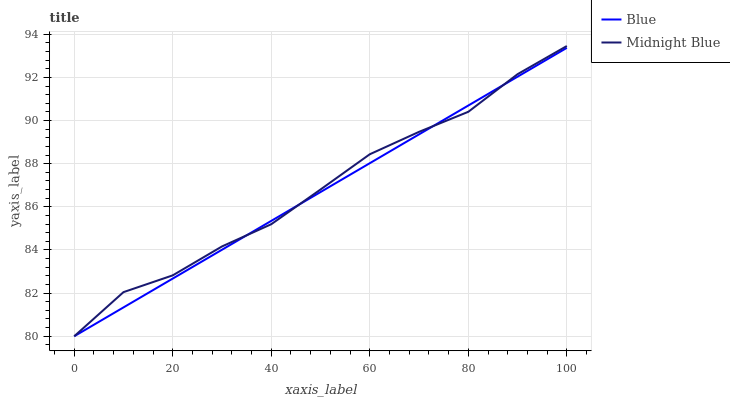Does Blue have the minimum area under the curve?
Answer yes or no. Yes. Does Midnight Blue have the maximum area under the curve?
Answer yes or no. Yes. Does Midnight Blue have the minimum area under the curve?
Answer yes or no. No. Is Blue the smoothest?
Answer yes or no. Yes. Is Midnight Blue the roughest?
Answer yes or no. Yes. Is Midnight Blue the smoothest?
Answer yes or no. No. Does Blue have the lowest value?
Answer yes or no. Yes. Does Midnight Blue have the highest value?
Answer yes or no. Yes. Does Midnight Blue intersect Blue?
Answer yes or no. Yes. Is Midnight Blue less than Blue?
Answer yes or no. No. Is Midnight Blue greater than Blue?
Answer yes or no. No. 